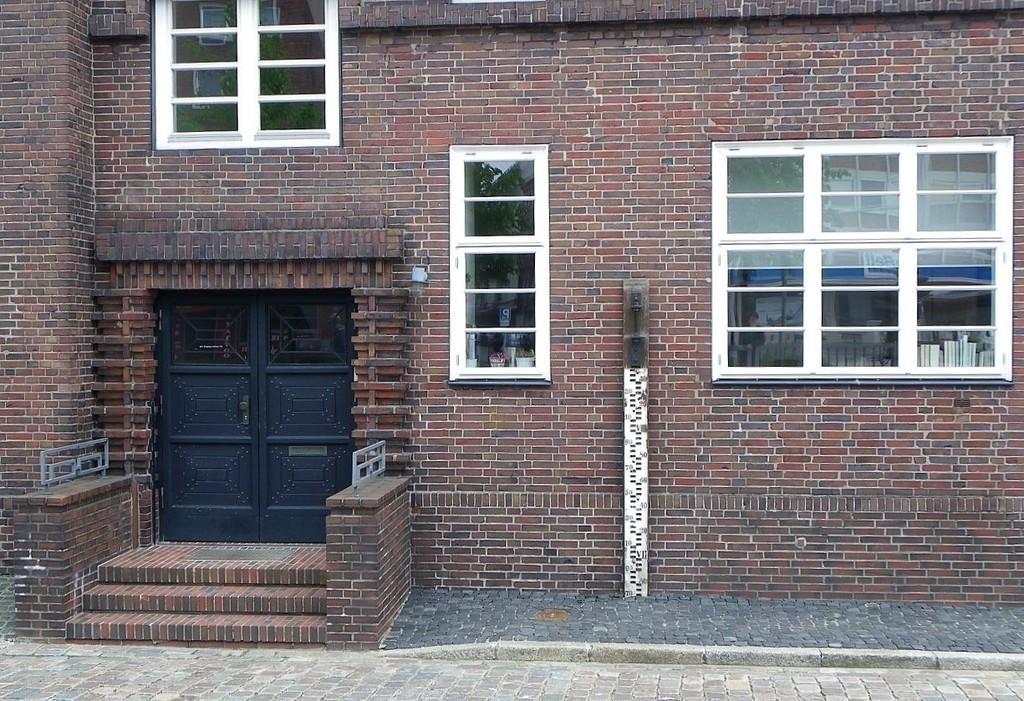What is the main structure in the center of the image? There is a house in the center of the image. What features can be seen on the house? The house has windows, walls, and a staircase. Is there any path or walkway visible in the image? Yes, there is a walkway at the bottom of the image. How does the house aid in the digestion process of the people living inside? The house does not aid in the digestion process; it is a structure for living and does not have any direct impact on digestion. 